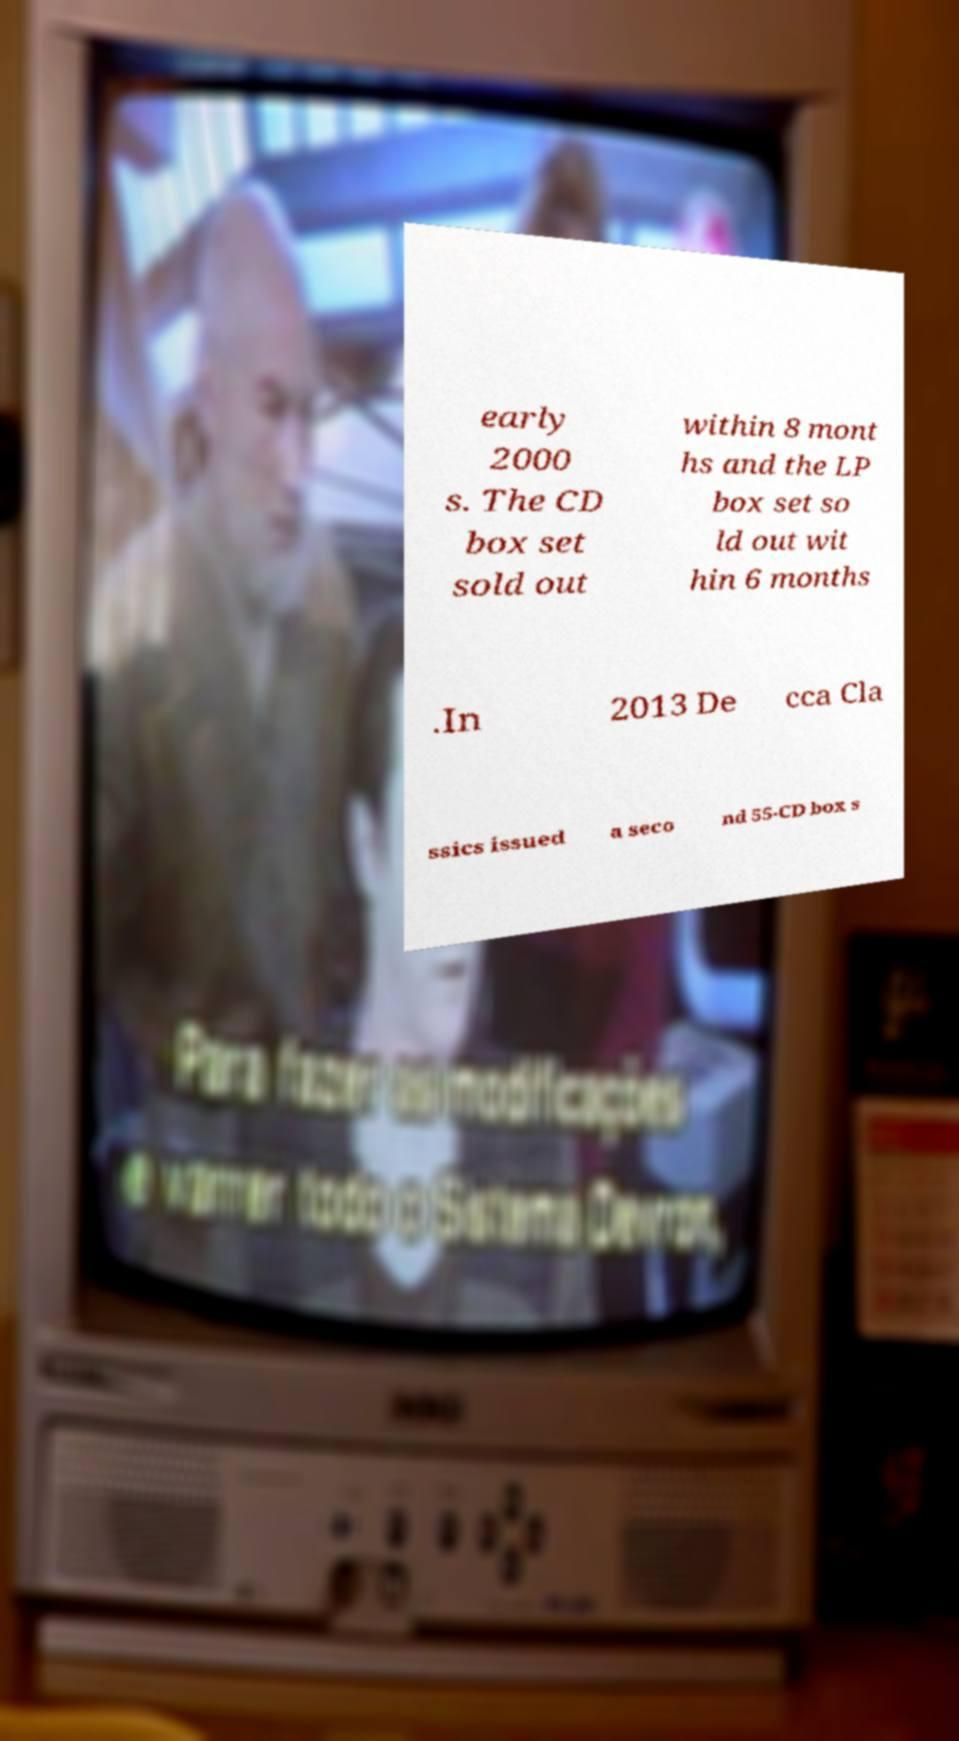Can you read and provide the text displayed in the image?This photo seems to have some interesting text. Can you extract and type it out for me? early 2000 s. The CD box set sold out within 8 mont hs and the LP box set so ld out wit hin 6 months .In 2013 De cca Cla ssics issued a seco nd 55-CD box s 